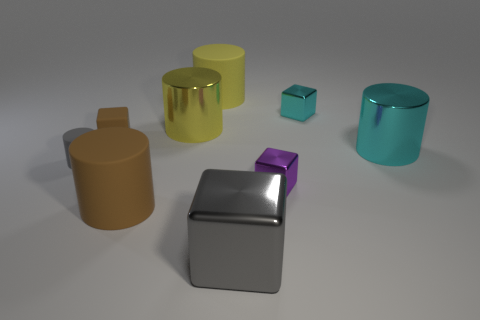Are the brown thing that is in front of the tiny matte cube and the gray object that is left of the big brown matte thing made of the same material?
Offer a very short reply. Yes. What is the material of the cyan object that is the same shape as the gray metal object?
Your response must be concise. Metal. Is the material of the brown cube the same as the tiny gray cylinder?
Make the answer very short. Yes. There is a big rubber object that is behind the big rubber cylinder in front of the big cyan shiny object; what color is it?
Give a very brief answer. Yellow. What is the size of the yellow object that is made of the same material as the brown block?
Your response must be concise. Large. How many tiny brown rubber things are the same shape as the big cyan metal thing?
Your answer should be compact. 0. How many objects are blocks that are to the left of the cyan block or large metal objects that are on the left side of the purple shiny object?
Ensure brevity in your answer.  4. There is a big matte cylinder that is behind the purple cube; how many small objects are on the left side of it?
Give a very brief answer. 2. Does the tiny cyan shiny object that is to the right of the big block have the same shape as the big shiny thing that is in front of the small gray matte thing?
Offer a very short reply. Yes. The thing that is the same color as the small rubber cube is what shape?
Provide a succinct answer. Cylinder. 